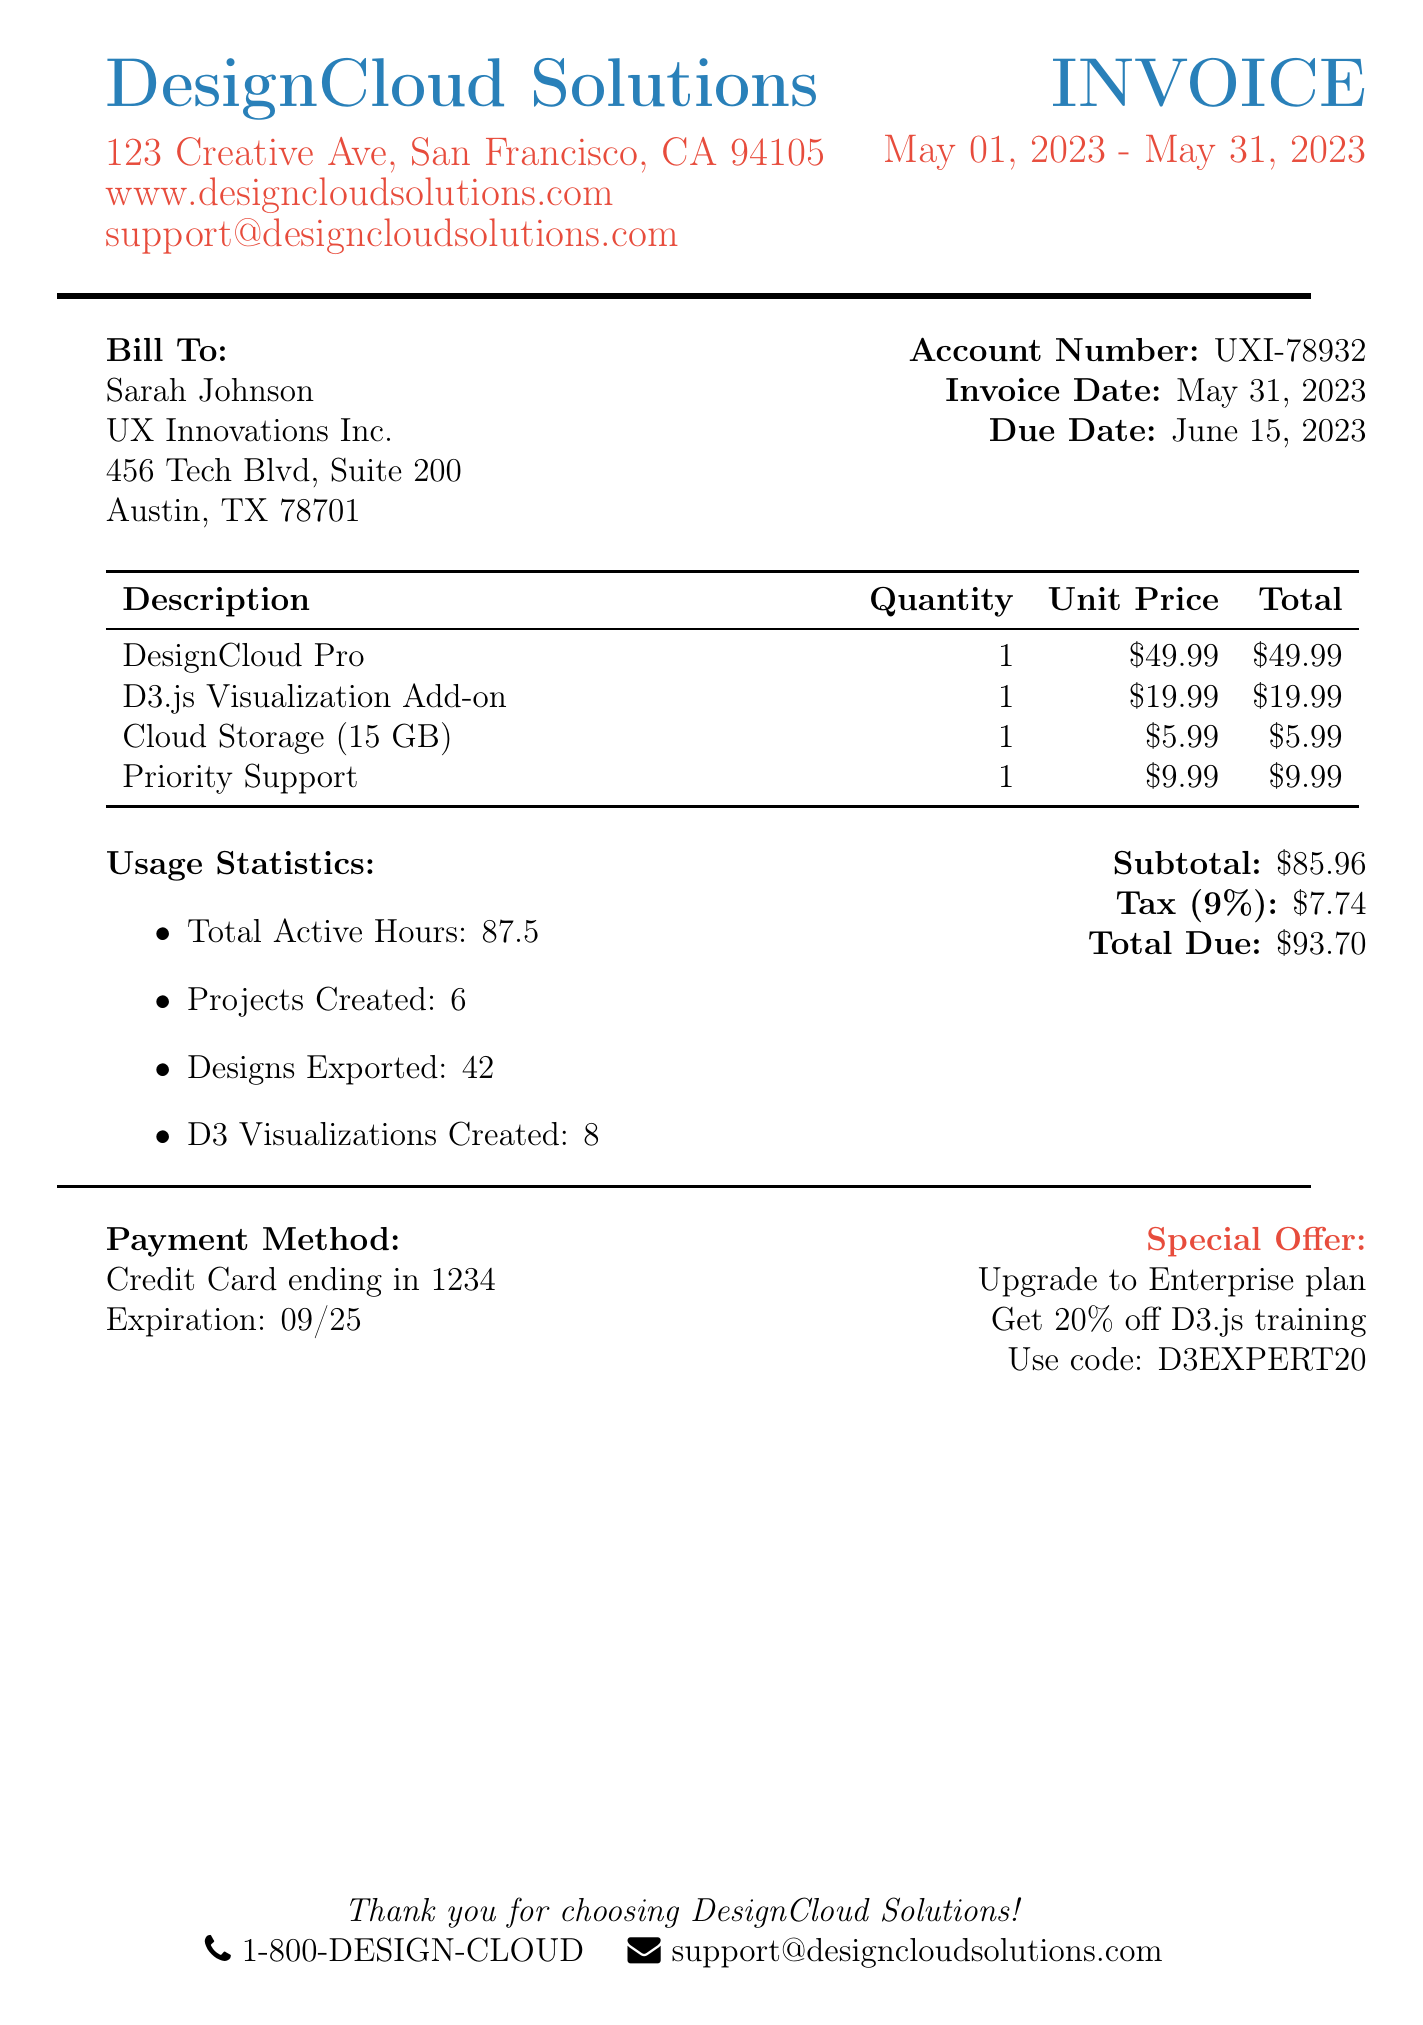what is the name of the billing company? The billing company is stated in the company information section of the document.
Answer: DesignCloud Solutions what is the total due amount? The total amount due is calculated from the payment summary in the document.
Answer: 93.70 how many team members contributed to the projects? The number of team members is listed under the collaboration features section.
Answer: 3 what is the subscription name for the enhanced data visualization tools? The name of the subscription is provided in the subscriptions section.
Answer: D3.js Visualization Add-on how many designs were exported? The number of designs exported is mentioned in the usage statistics section.
Answer: 42 what is the account number for the client? The account number for the client is specified in the client information section.
Answer: UXI-78932 how many support tickets were used? The number of support tickets is detailed in the additional services section.
Answer: 2 support tickets what is the tax amount charged? The tax amount is provided in the payment summary of the document.
Answer: 7.74 what is the special offer mentioned in the document? The special offer is outlined towards the end of the document.
Answer: Upgrade to Enterprise plan 